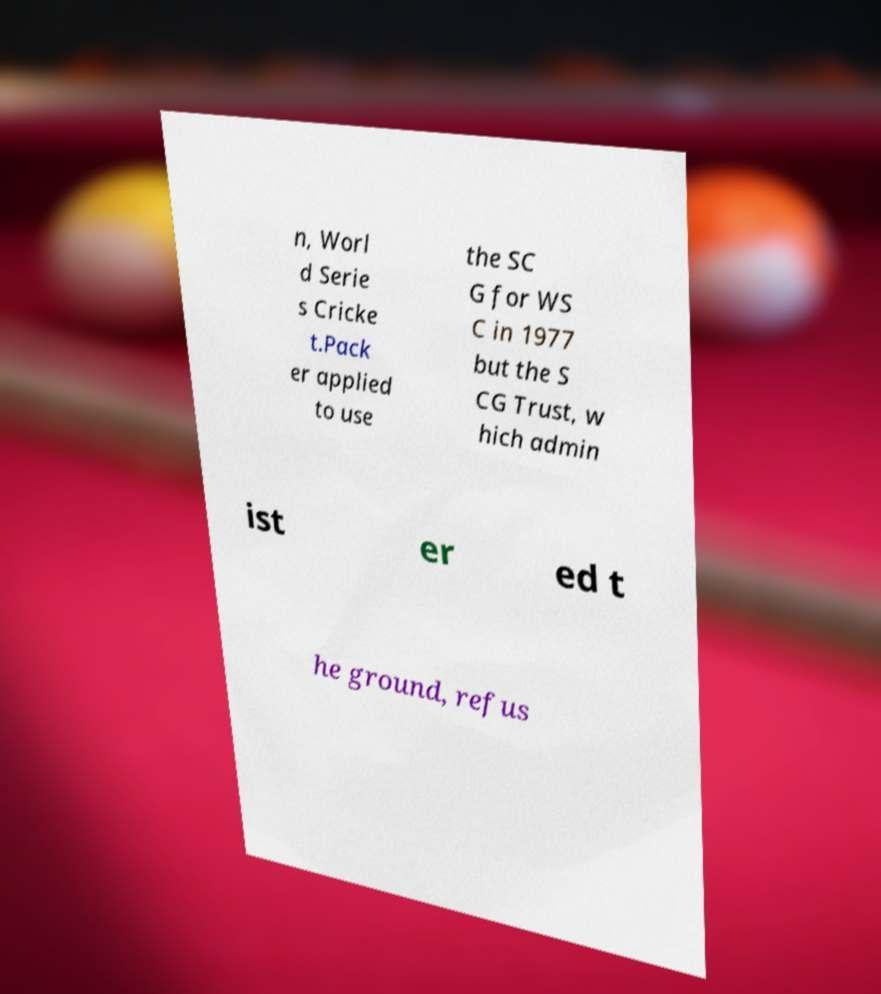I need the written content from this picture converted into text. Can you do that? n, Worl d Serie s Cricke t.Pack er applied to use the SC G for WS C in 1977 but the S CG Trust, w hich admin ist er ed t he ground, refus 